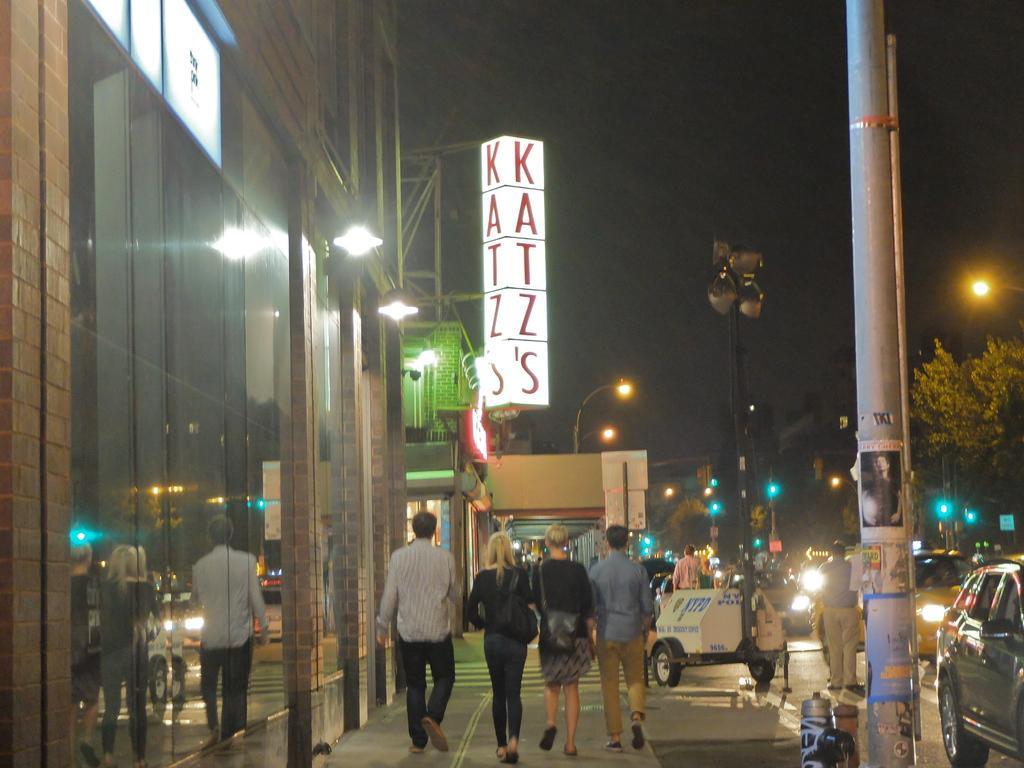In one or two sentences, can you explain what this image depicts? In this image I can see few people are walking on the road. I can see few vehicles,trees,light-poles,poles,boards and glass buildings. 